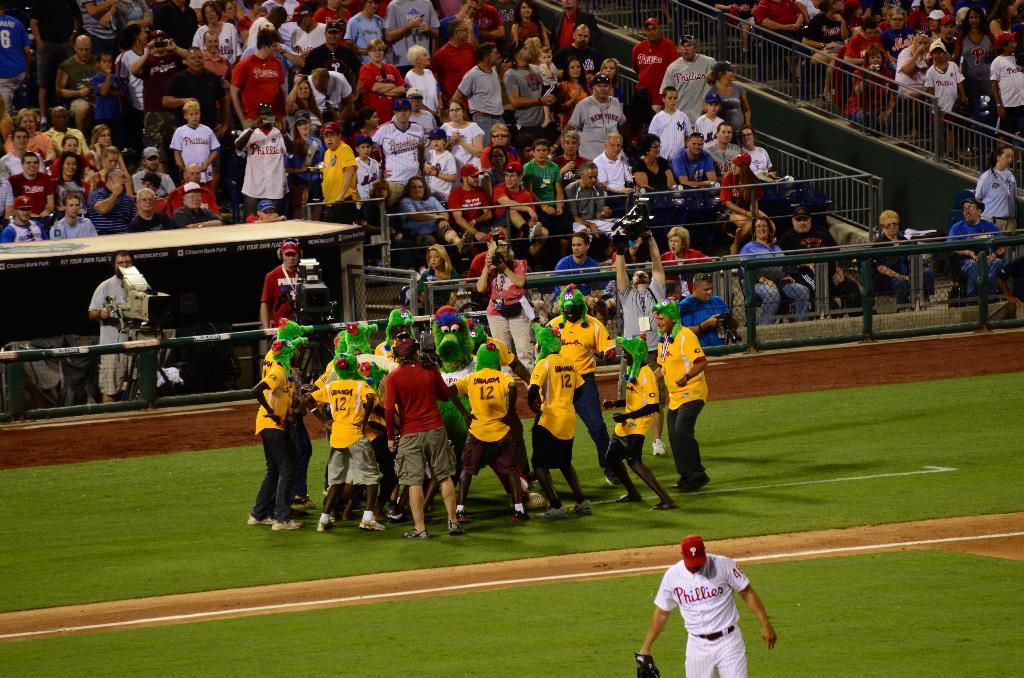What are the people in the image doing? The people in the image are dancing. Where is the dancing taking place? The dancing is taking place on a ground. What can be seen in the background of the image? There is a fencing in the background of the image, as well as people sitting on chairs and people standing. Can you see any signs of the winter season in the image? There is no indication of the winter season in the image; it does not show any snow, ice, or cold-weather clothing. 